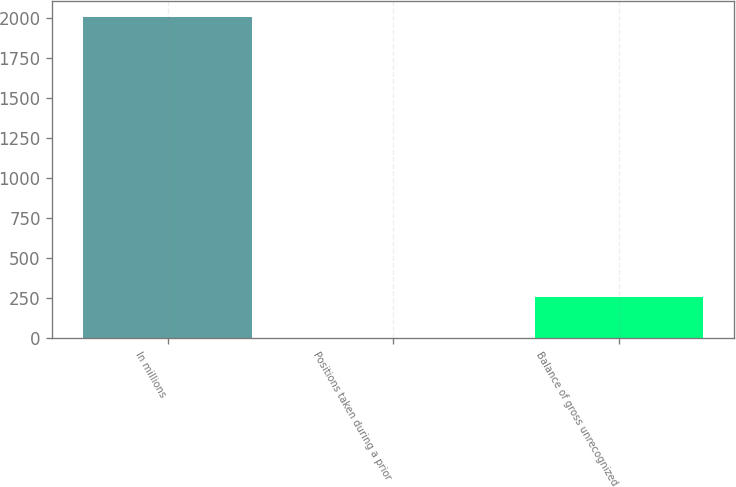Convert chart. <chart><loc_0><loc_0><loc_500><loc_500><bar_chart><fcel>In millions<fcel>Positions taken during a prior<fcel>Balance of gross unrecognized<nl><fcel>2008<fcel>3<fcel>257<nl></chart> 